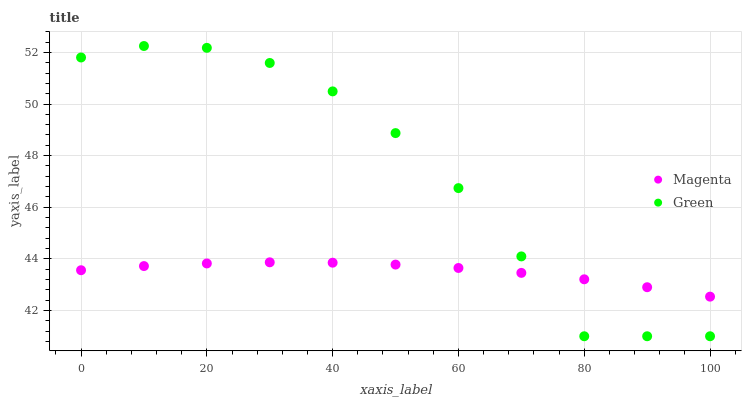Does Magenta have the minimum area under the curve?
Answer yes or no. Yes. Does Green have the maximum area under the curve?
Answer yes or no. Yes. Does Green have the minimum area under the curve?
Answer yes or no. No. Is Magenta the smoothest?
Answer yes or no. Yes. Is Green the roughest?
Answer yes or no. Yes. Is Green the smoothest?
Answer yes or no. No. Does Green have the lowest value?
Answer yes or no. Yes. Does Green have the highest value?
Answer yes or no. Yes. Does Green intersect Magenta?
Answer yes or no. Yes. Is Green less than Magenta?
Answer yes or no. No. Is Green greater than Magenta?
Answer yes or no. No. 